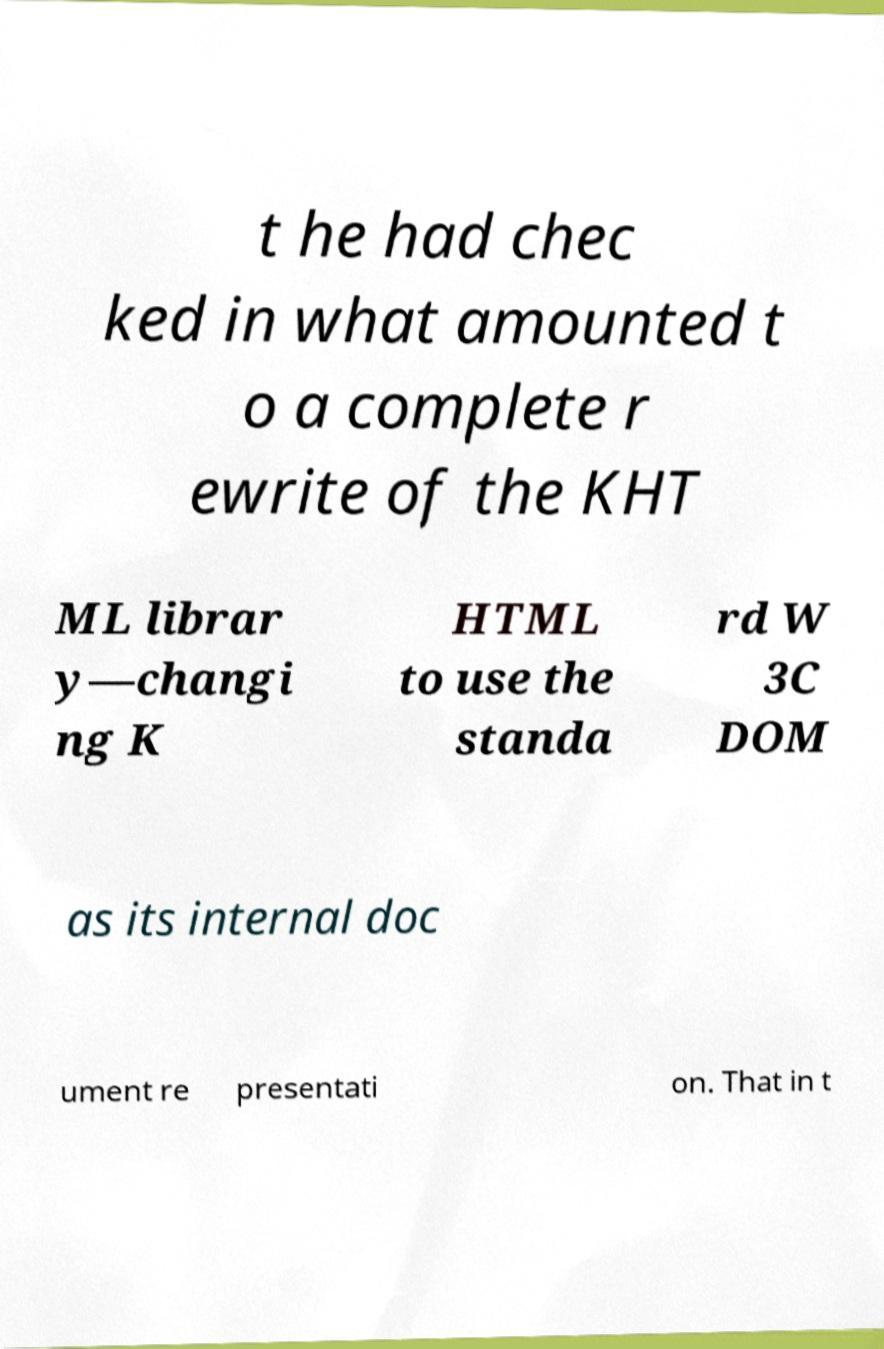What messages or text are displayed in this image? I need them in a readable, typed format. t he had chec ked in what amounted t o a complete r ewrite of the KHT ML librar y—changi ng K HTML to use the standa rd W 3C DOM as its internal doc ument re presentati on. That in t 